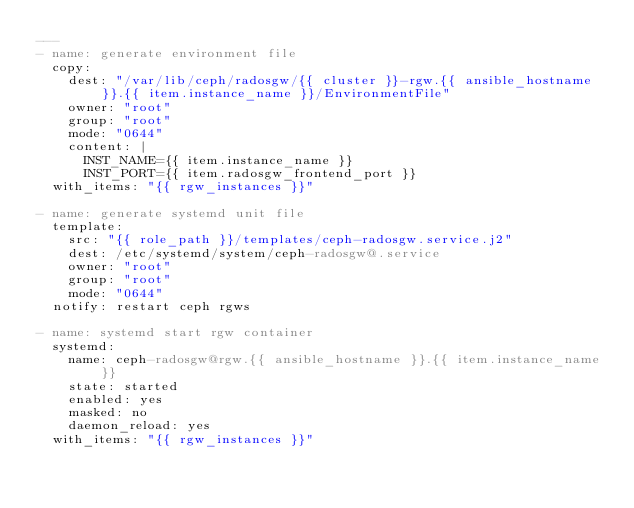<code> <loc_0><loc_0><loc_500><loc_500><_YAML_>---
- name: generate environment file
  copy:
    dest: "/var/lib/ceph/radosgw/{{ cluster }}-rgw.{{ ansible_hostname }}.{{ item.instance_name }}/EnvironmentFile"
    owner: "root"
    group: "root"
    mode: "0644"
    content: |
      INST_NAME={{ item.instance_name }}
      INST_PORT={{ item.radosgw_frontend_port }}
  with_items: "{{ rgw_instances }}"

- name: generate systemd unit file
  template:
    src: "{{ role_path }}/templates/ceph-radosgw.service.j2"
    dest: /etc/systemd/system/ceph-radosgw@.service
    owner: "root"
    group: "root"
    mode: "0644"
  notify: restart ceph rgws

- name: systemd start rgw container
  systemd:
    name: ceph-radosgw@rgw.{{ ansible_hostname }}.{{ item.instance_name }}
    state: started
    enabled: yes
    masked: no
    daemon_reload: yes
  with_items: "{{ rgw_instances }}"
</code> 